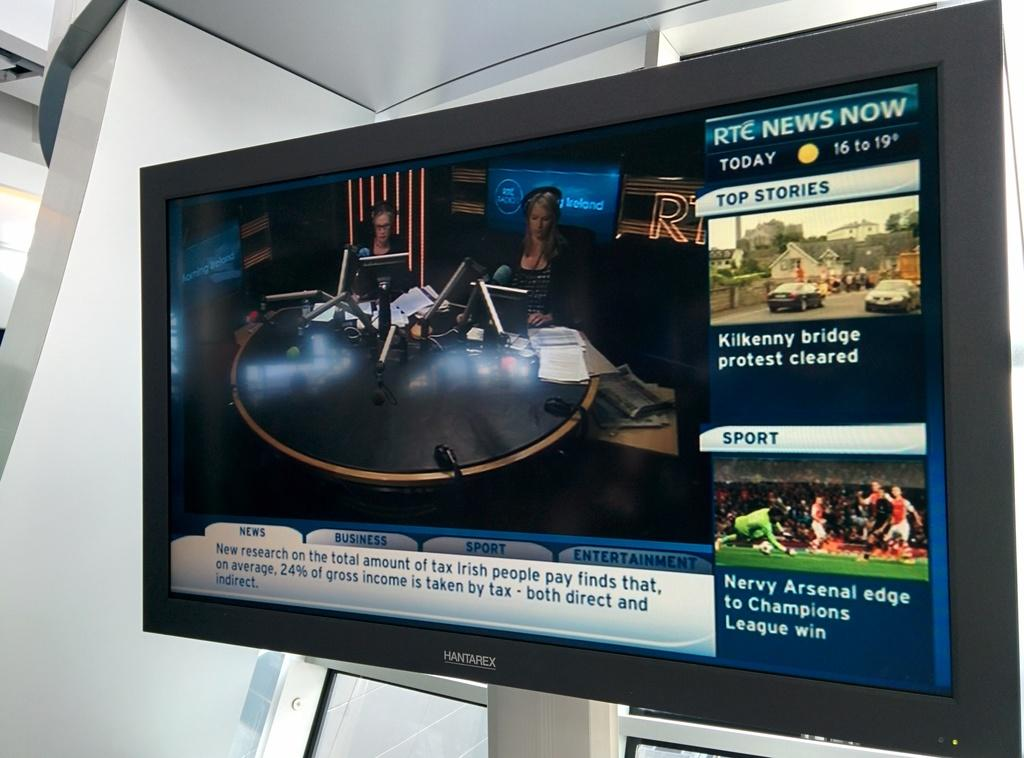<image>
Create a compact narrative representing the image presented. A tv with a sport section has people playing soccer. 